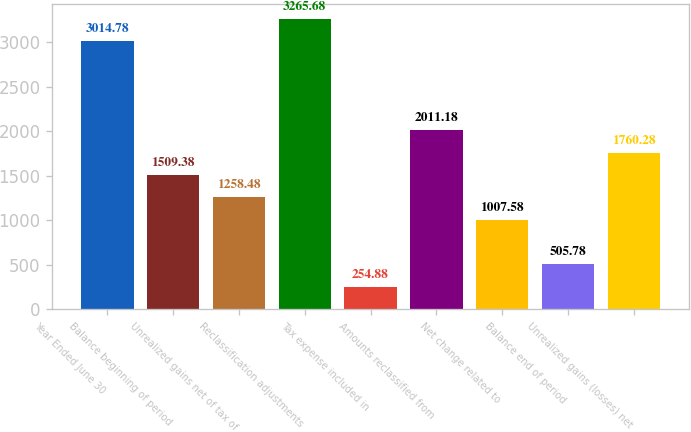<chart> <loc_0><loc_0><loc_500><loc_500><bar_chart><fcel>Year Ended June 30<fcel>Balance beginning of period<fcel>Unrealized gains net of tax of<fcel>Reclassification adjustments<fcel>Tax expense included in<fcel>Amounts reclassified from<fcel>Net change related to<fcel>Balance end of period<fcel>Unrealized gains (losses) net<nl><fcel>3014.78<fcel>1509.38<fcel>1258.48<fcel>3265.68<fcel>254.88<fcel>2011.18<fcel>1007.58<fcel>505.78<fcel>1760.28<nl></chart> 